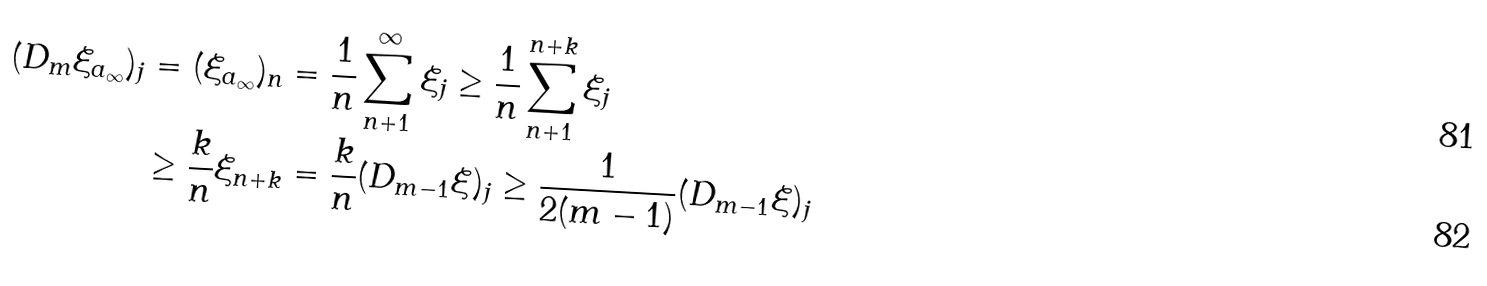Convert formula to latex. <formula><loc_0><loc_0><loc_500><loc_500>( D _ { m } \xi _ { a _ { \infty } } ) _ { j } & = ( \xi _ { a _ { \infty } } ) _ { n } = \frac { 1 } { n } \sum _ { n + 1 } ^ { \infty } \xi _ { j } \geq \frac { 1 } { n } \sum _ { n + 1 } ^ { n + k } \xi _ { j } \\ & \geq \frac { k } { n } \xi _ { n + k } = \frac { k } { n } ( D _ { m - 1 } \xi ) _ { j } \geq \frac { 1 } { 2 ( m - 1 ) } ( D _ { m - 1 } \xi ) _ { j }</formula> 